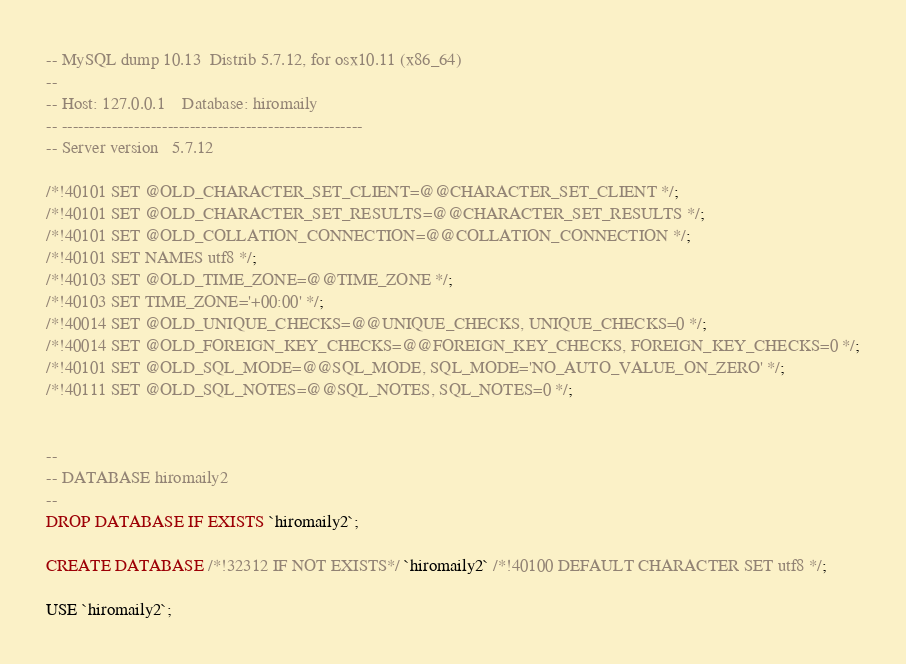<code> <loc_0><loc_0><loc_500><loc_500><_SQL_>-- MySQL dump 10.13  Distrib 5.7.12, for osx10.11 (x86_64)
--
-- Host: 127.0.0.1    Database: hiromaily
-- ------------------------------------------------------
-- Server version	5.7.12

/*!40101 SET @OLD_CHARACTER_SET_CLIENT=@@CHARACTER_SET_CLIENT */;
/*!40101 SET @OLD_CHARACTER_SET_RESULTS=@@CHARACTER_SET_RESULTS */;
/*!40101 SET @OLD_COLLATION_CONNECTION=@@COLLATION_CONNECTION */;
/*!40101 SET NAMES utf8 */;
/*!40103 SET @OLD_TIME_ZONE=@@TIME_ZONE */;
/*!40103 SET TIME_ZONE='+00:00' */;
/*!40014 SET @OLD_UNIQUE_CHECKS=@@UNIQUE_CHECKS, UNIQUE_CHECKS=0 */;
/*!40014 SET @OLD_FOREIGN_KEY_CHECKS=@@FOREIGN_KEY_CHECKS, FOREIGN_KEY_CHECKS=0 */;
/*!40101 SET @OLD_SQL_MODE=@@SQL_MODE, SQL_MODE='NO_AUTO_VALUE_ON_ZERO' */;
/*!40111 SET @OLD_SQL_NOTES=@@SQL_NOTES, SQL_NOTES=0 */;


--
-- DATABASE hiromaily2
--
DROP DATABASE IF EXISTS `hiromaily2`;

CREATE DATABASE /*!32312 IF NOT EXISTS*/ `hiromaily2` /*!40100 DEFAULT CHARACTER SET utf8 */;

USE `hiromaily2`;
</code> 